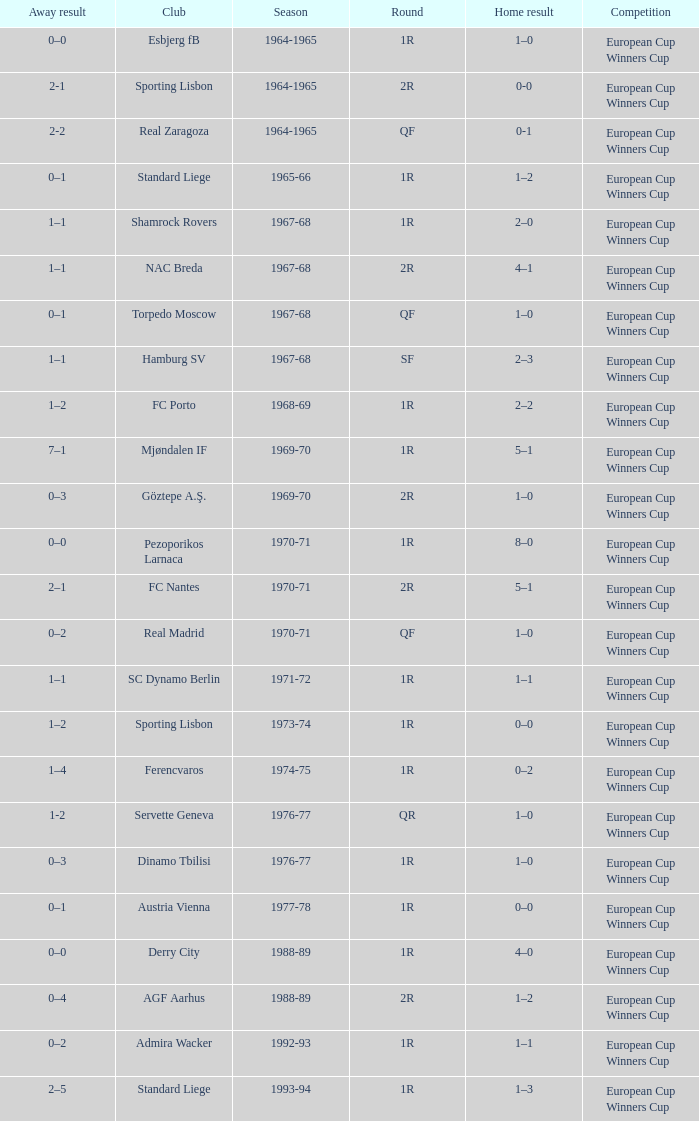Away result of 0–3, and a Season of 1969-70 is what competition? European Cup Winners Cup. 